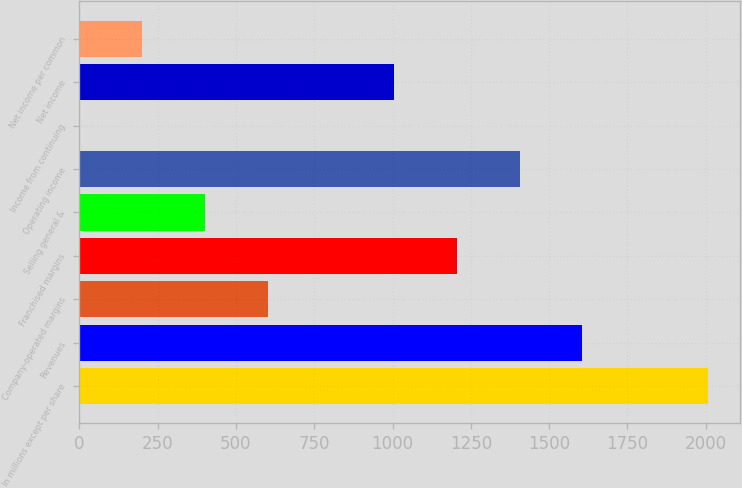Convert chart. <chart><loc_0><loc_0><loc_500><loc_500><bar_chart><fcel>In millions except per share<fcel>Revenues<fcel>Company-operated margins<fcel>Franchised margins<fcel>Selling general &<fcel>Operating income<fcel>Income from continuing<fcel>Net income<fcel>Net income per common<nl><fcel>2008<fcel>1606.41<fcel>602.46<fcel>1204.83<fcel>401.67<fcel>1405.62<fcel>0.09<fcel>1004.04<fcel>200.88<nl></chart> 